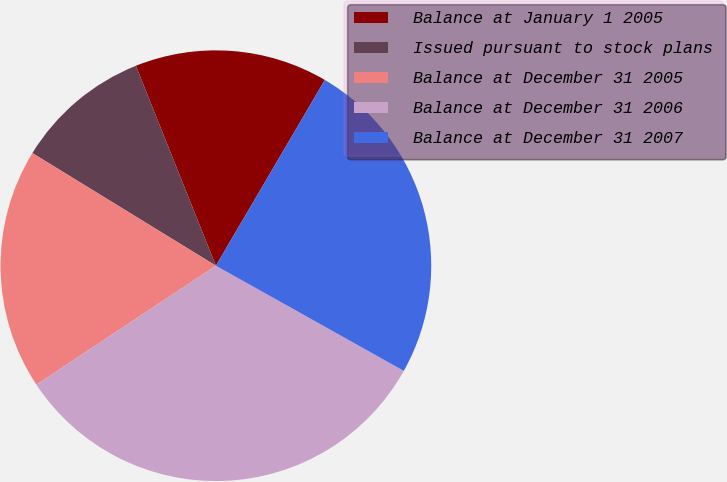Convert chart to OTSL. <chart><loc_0><loc_0><loc_500><loc_500><pie_chart><fcel>Balance at January 1 2005<fcel>Issued pursuant to stock plans<fcel>Balance at December 31 2005<fcel>Balance at December 31 2006<fcel>Balance at December 31 2007<nl><fcel>14.5%<fcel>10.18%<fcel>18.07%<fcel>32.57%<fcel>24.68%<nl></chart> 